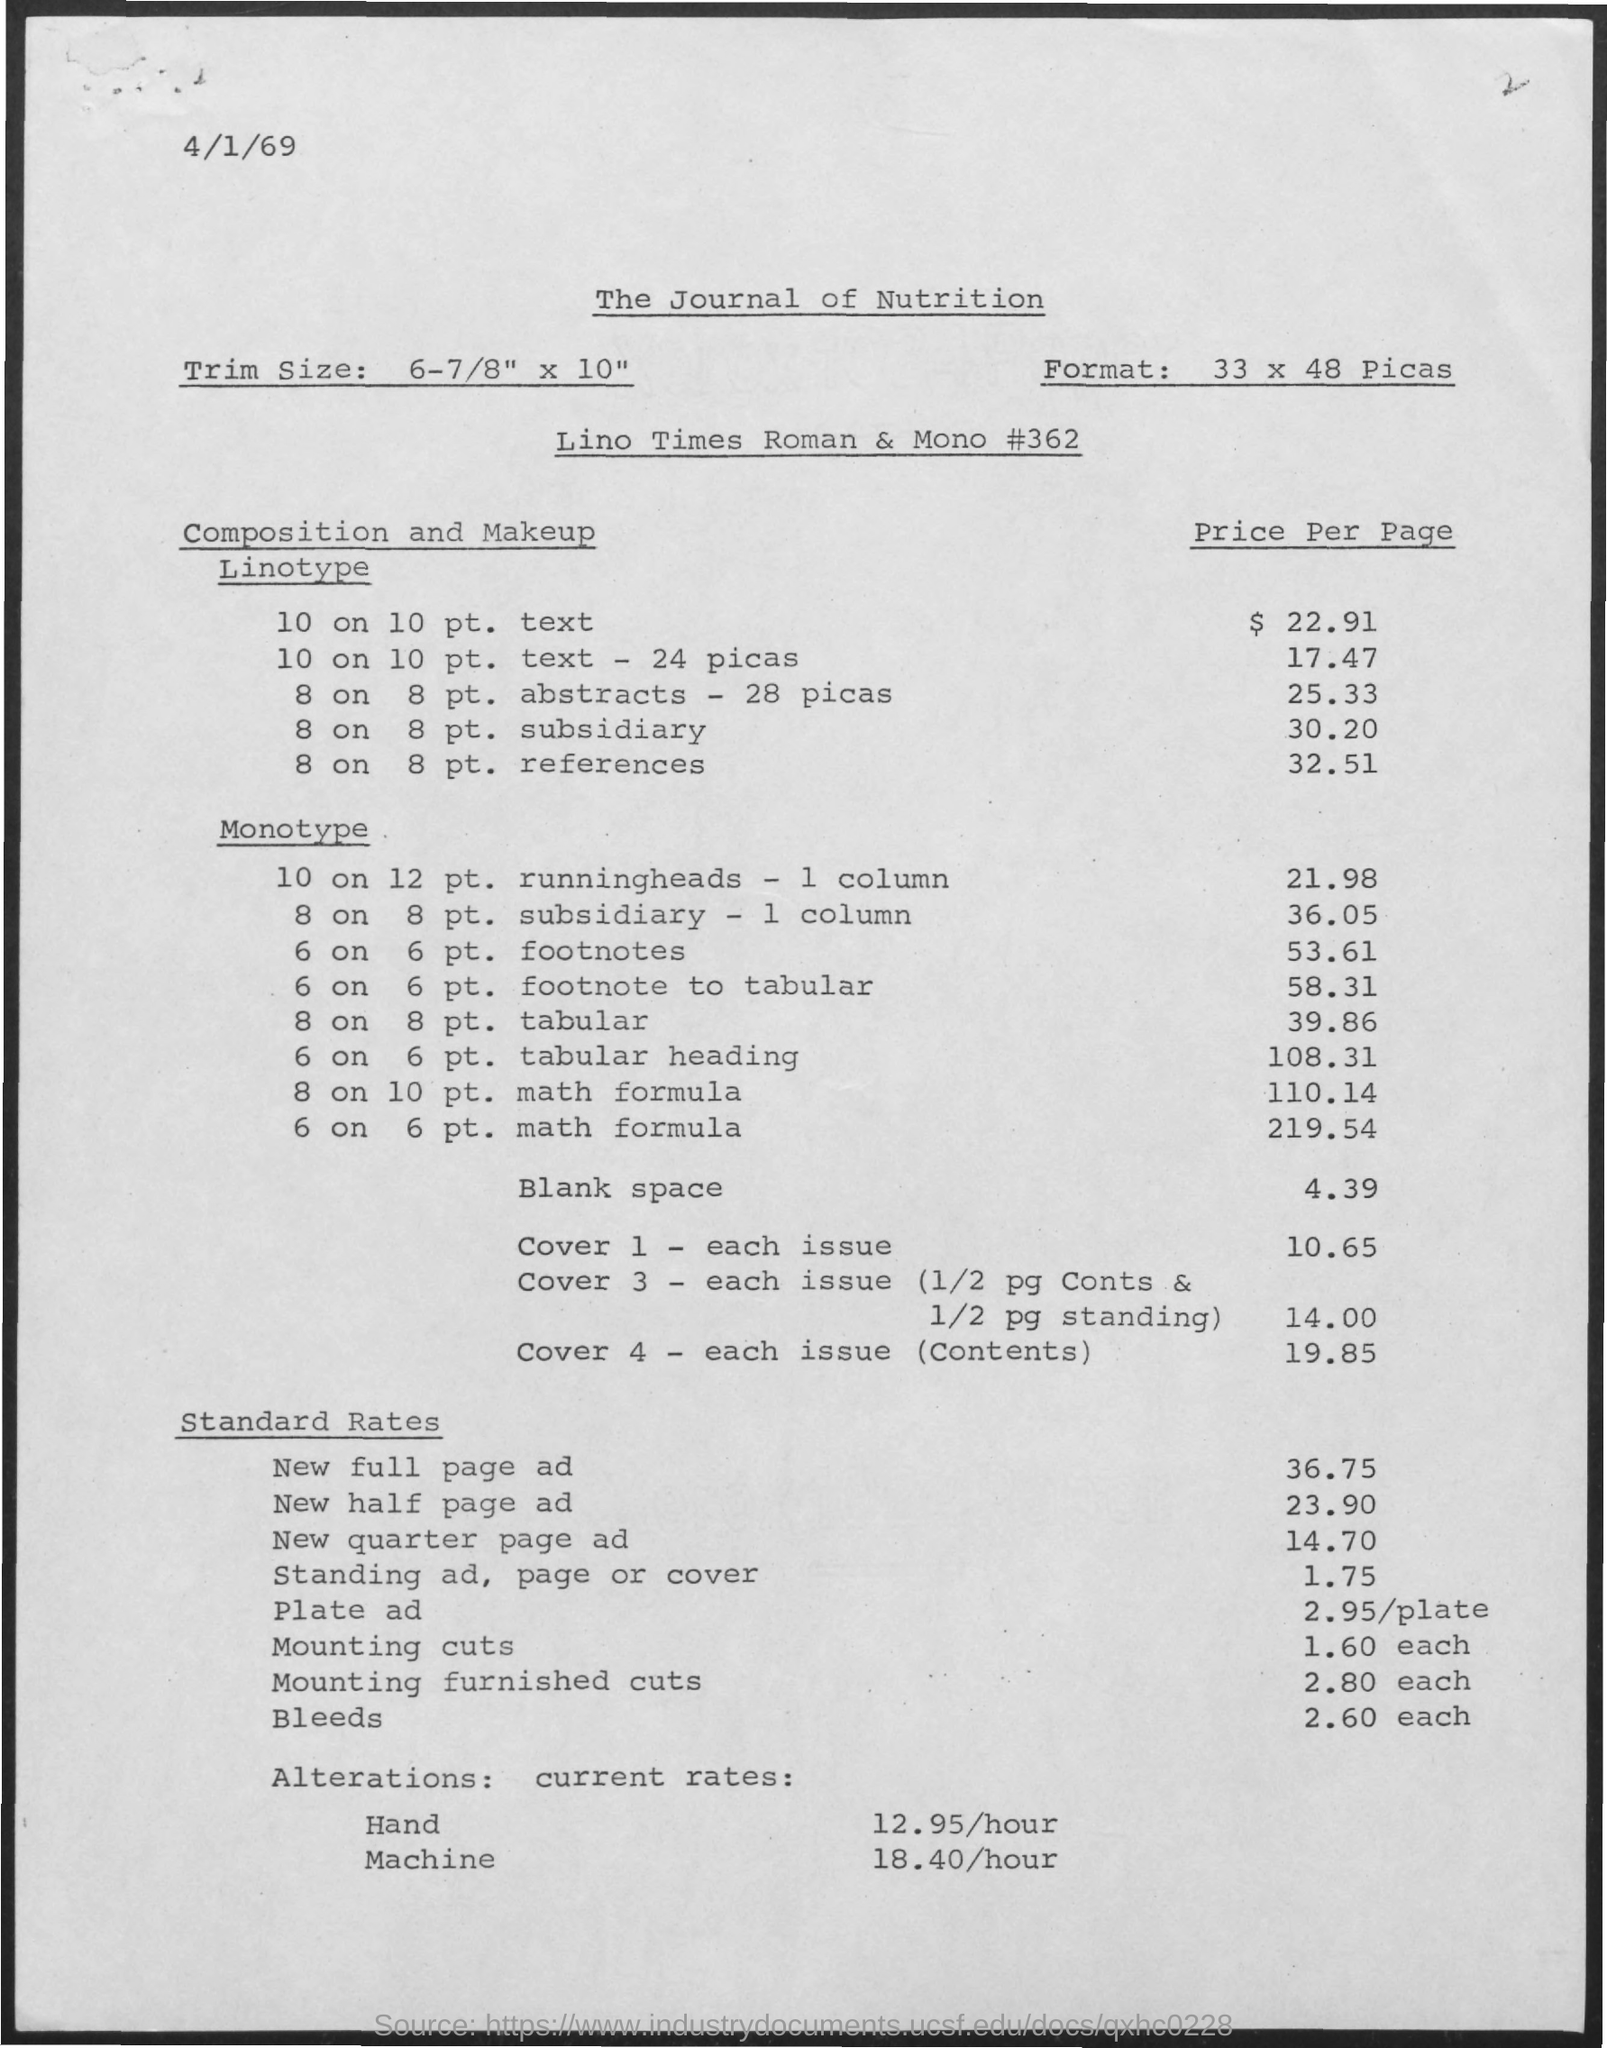What is the format ?
Provide a succinct answer. 33 x 48 picas. What is the trim size ?
Offer a terse response. 6-7/8" x 10". What is the title at top of page?
Give a very brief answer. The journal of nutrition. What is the date at top of the page?
Make the answer very short. 4/1/69. What is the price per page for linotype of 10 on 10pt. text?
Offer a terse response. $ 22.91. What is price per page for linotype of 10 on 10pt. text -24 picas?
Offer a very short reply. 17.47. What is price per page for linotype of 8 on 8pt. abstracts -28 picas?
Make the answer very short. $25.33. What is price per page for monotype of 10 on 12 pt. runningheads - 1 column?
Offer a very short reply. 21.98. 